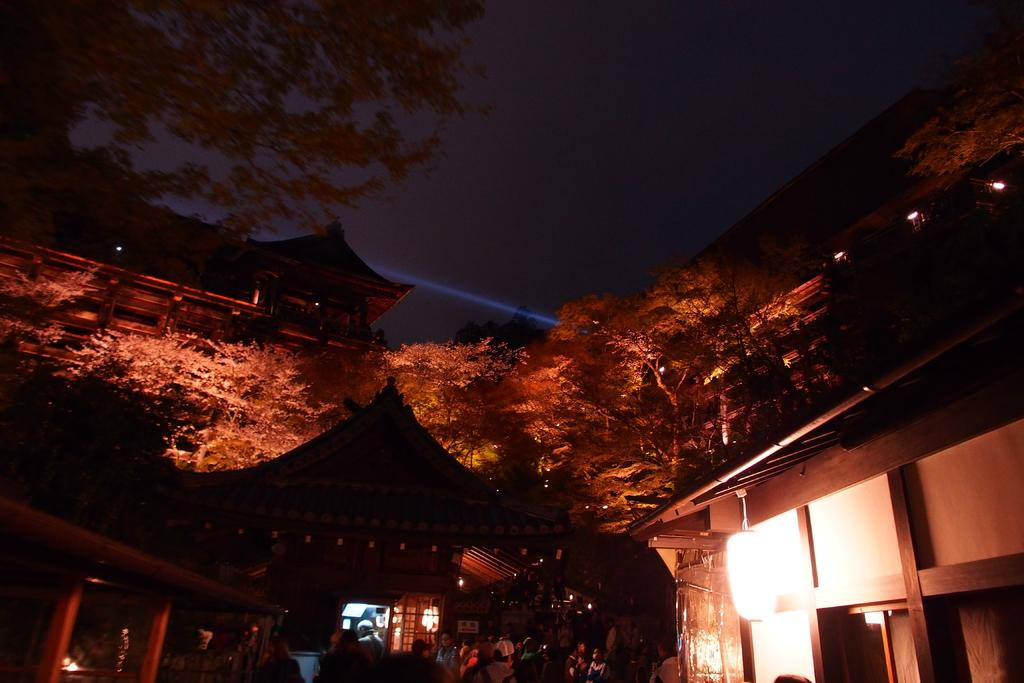How many people are in the image? There is a group of persons standing in the image. What structures can be seen in the image? There are houses in the image. What type of vegetation is visible in the background of the image? There are trees in the background of the image. What is the color of the sky in the background of the image? The sky is dark in the background of the image. Where is the soda being stored in the image? There is no soda present in the image. How many kittens are playing in the hall in the image? There are no kittens or halls present in the image. 